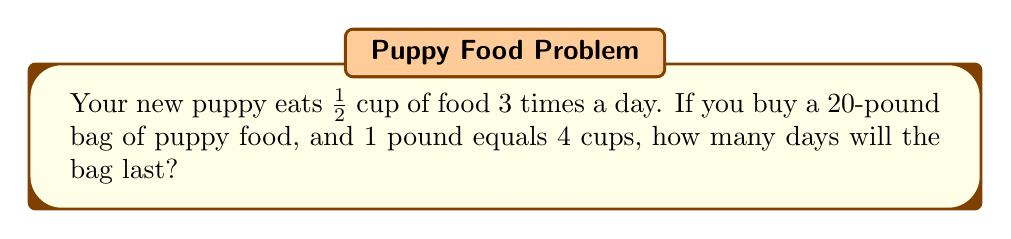What is the answer to this math problem? Let's break this down step-by-step:

1. Calculate how much food your puppy eats per day:
   $\frac{1}{2}$ cup × 3 times = $\frac{3}{2}$ cups per day

2. Convert the bag size from pounds to cups:
   20 pounds × 4 cups/pound = 80 cups in the bag

3. Set up the division to find how many days the bag will last:
   $$ \text{Days} = \frac{\text{Total cups in bag}}{\text{Cups eaten per day}} $$

4. Plug in the values:
   $$ \text{Days} = \frac{80 \text{ cups}}{\frac{3}{2} \text{ cups/day}} $$

5. Simplify the division:
   $$ \text{Days} = 80 \div \frac{3}{2} = 80 \times \frac{2}{3} = \frac{160}{3} $$

6. Calculate the final result:
   $\frac{160}{3} = 53\frac{1}{3}$ days

Therefore, the 20-pound bag of puppy food will last for 53 full days, with some left over for part of the 54th day.
Answer: 53 days 